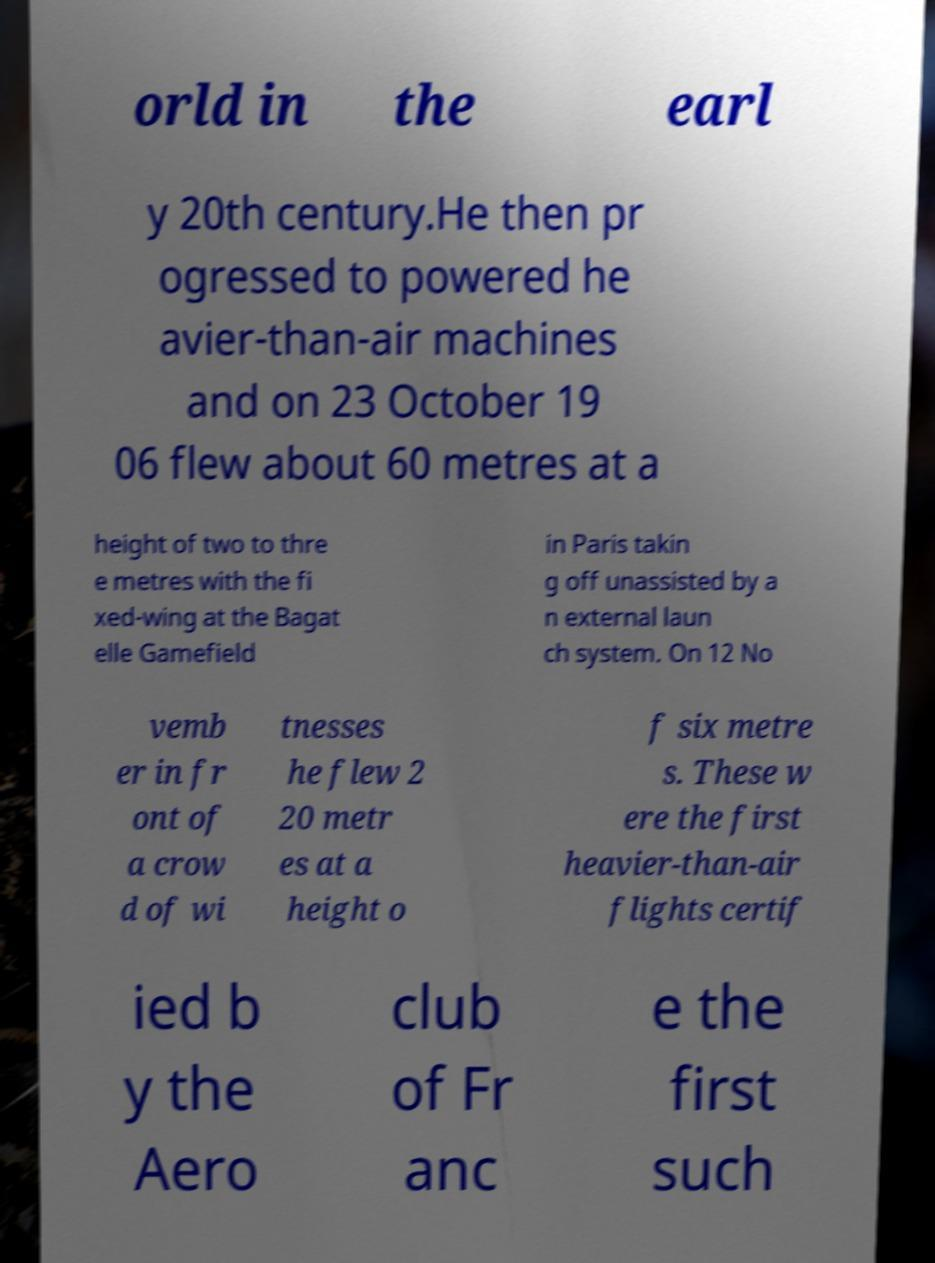Can you accurately transcribe the text from the provided image for me? orld in the earl y 20th century.He then pr ogressed to powered he avier-than-air machines and on 23 October 19 06 flew about 60 metres at a height of two to thre e metres with the fi xed-wing at the Bagat elle Gamefield in Paris takin g off unassisted by a n external laun ch system. On 12 No vemb er in fr ont of a crow d of wi tnesses he flew 2 20 metr es at a height o f six metre s. These w ere the first heavier-than-air flights certif ied b y the Aero club of Fr anc e the first such 